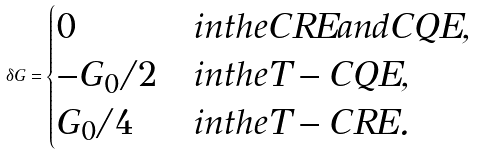Convert formula to latex. <formula><loc_0><loc_0><loc_500><loc_500>\delta G = \begin{cases} 0 & i n t h e C R E a n d C Q E , \\ - G _ { 0 } / 2 & i n t h e T - C Q E , \\ G _ { 0 } / 4 & i n t h e T - C R E . \end{cases}</formula> 